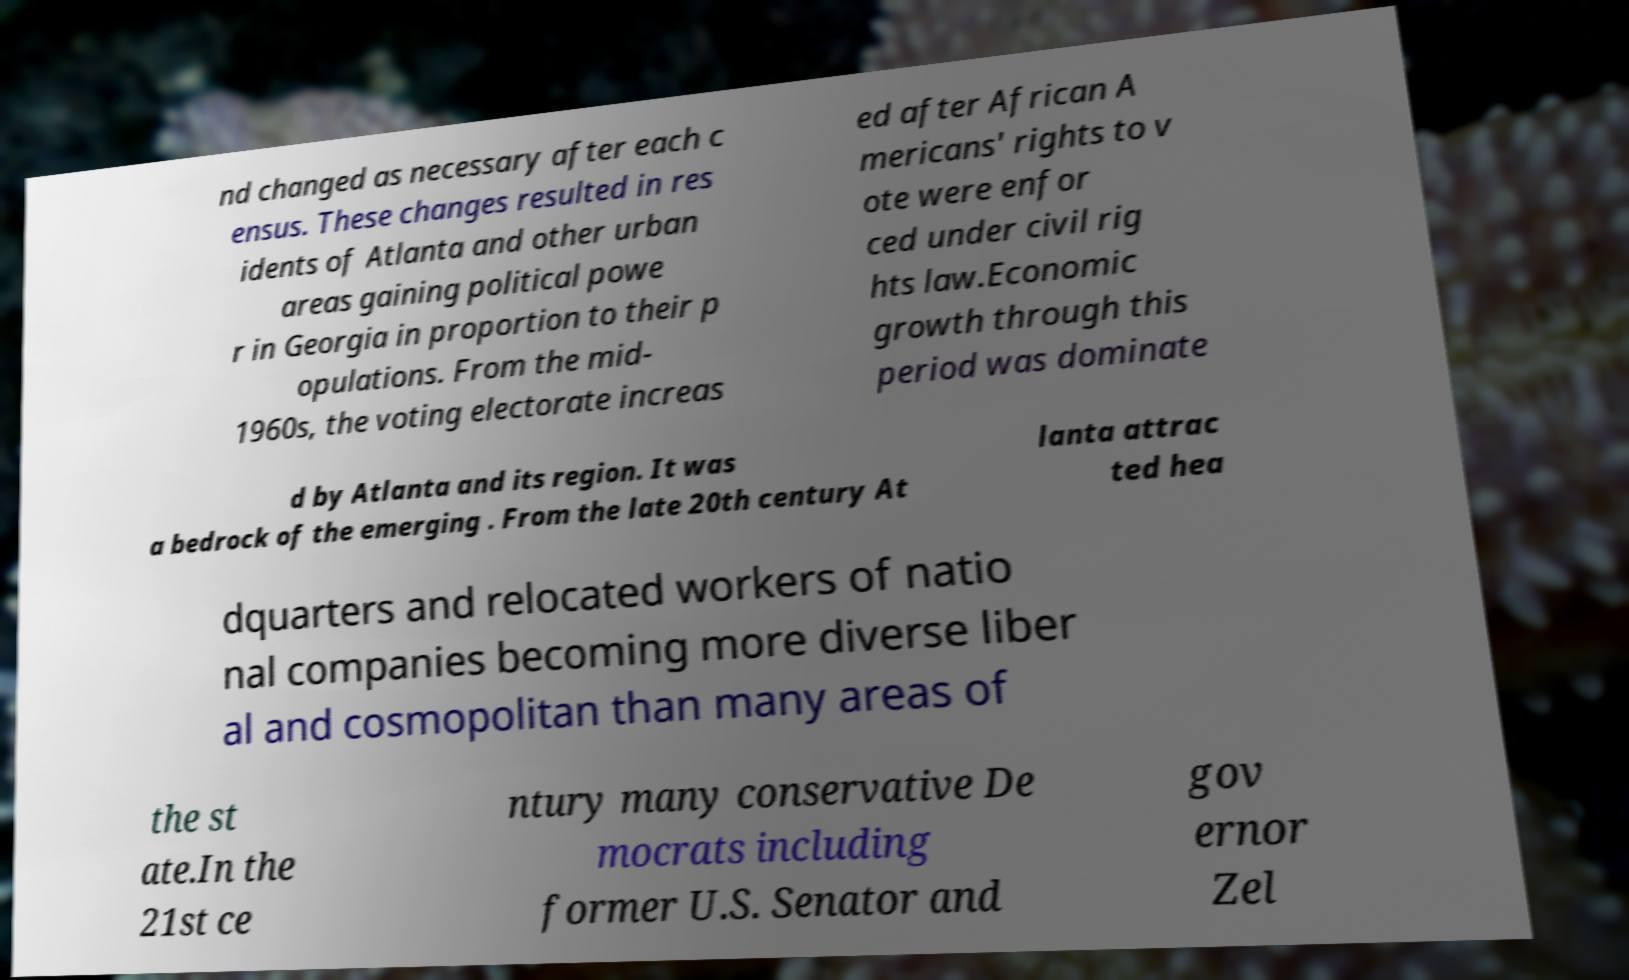I need the written content from this picture converted into text. Can you do that? nd changed as necessary after each c ensus. These changes resulted in res idents of Atlanta and other urban areas gaining political powe r in Georgia in proportion to their p opulations. From the mid- 1960s, the voting electorate increas ed after African A mericans' rights to v ote were enfor ced under civil rig hts law.Economic growth through this period was dominate d by Atlanta and its region. It was a bedrock of the emerging . From the late 20th century At lanta attrac ted hea dquarters and relocated workers of natio nal companies becoming more diverse liber al and cosmopolitan than many areas of the st ate.In the 21st ce ntury many conservative De mocrats including former U.S. Senator and gov ernor Zel 